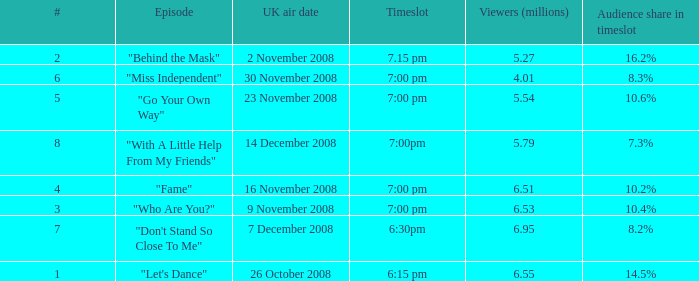Name the timeslot for 6.51 viewers 7:00 pm. 